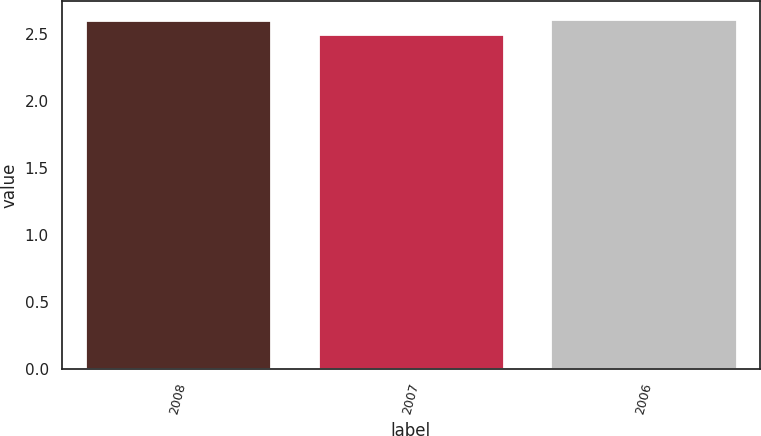Convert chart to OTSL. <chart><loc_0><loc_0><loc_500><loc_500><bar_chart><fcel>2008<fcel>2007<fcel>2006<nl><fcel>2.6<fcel>2.5<fcel>2.61<nl></chart> 